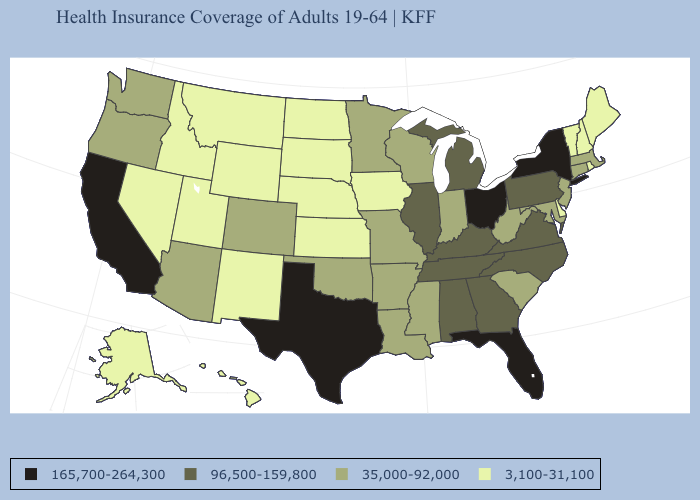Which states have the lowest value in the MidWest?
Write a very short answer. Iowa, Kansas, Nebraska, North Dakota, South Dakota. Does Florida have the highest value in the USA?
Write a very short answer. Yes. Does the first symbol in the legend represent the smallest category?
Keep it brief. No. What is the lowest value in the USA?
Be succinct. 3,100-31,100. What is the highest value in the USA?
Quick response, please. 165,700-264,300. Name the states that have a value in the range 35,000-92,000?
Quick response, please. Arizona, Arkansas, Colorado, Connecticut, Indiana, Louisiana, Maryland, Massachusetts, Minnesota, Mississippi, Missouri, New Jersey, Oklahoma, Oregon, South Carolina, Washington, West Virginia, Wisconsin. What is the value of Massachusetts?
Answer briefly. 35,000-92,000. Name the states that have a value in the range 35,000-92,000?
Quick response, please. Arizona, Arkansas, Colorado, Connecticut, Indiana, Louisiana, Maryland, Massachusetts, Minnesota, Mississippi, Missouri, New Jersey, Oklahoma, Oregon, South Carolina, Washington, West Virginia, Wisconsin. Does Delaware have a lower value than Nevada?
Concise answer only. No. Among the states that border South Dakota , which have the highest value?
Quick response, please. Minnesota. Name the states that have a value in the range 3,100-31,100?
Be succinct. Alaska, Delaware, Hawaii, Idaho, Iowa, Kansas, Maine, Montana, Nebraska, Nevada, New Hampshire, New Mexico, North Dakota, Rhode Island, South Dakota, Utah, Vermont, Wyoming. Which states have the lowest value in the USA?
Quick response, please. Alaska, Delaware, Hawaii, Idaho, Iowa, Kansas, Maine, Montana, Nebraska, Nevada, New Hampshire, New Mexico, North Dakota, Rhode Island, South Dakota, Utah, Vermont, Wyoming. Name the states that have a value in the range 3,100-31,100?
Keep it brief. Alaska, Delaware, Hawaii, Idaho, Iowa, Kansas, Maine, Montana, Nebraska, Nevada, New Hampshire, New Mexico, North Dakota, Rhode Island, South Dakota, Utah, Vermont, Wyoming. What is the value of Oklahoma?
Keep it brief. 35,000-92,000. Does Vermont have the highest value in the Northeast?
Keep it brief. No. 